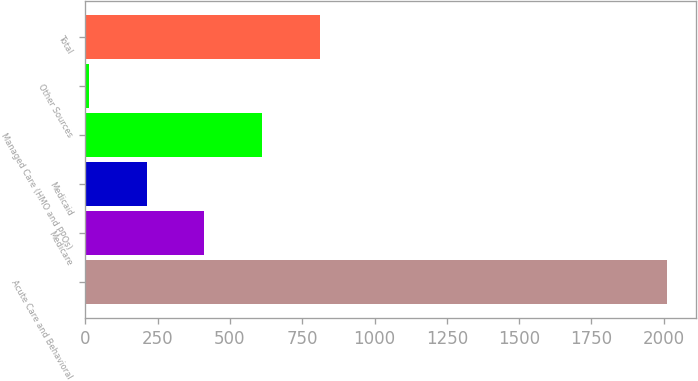Convert chart. <chart><loc_0><loc_0><loc_500><loc_500><bar_chart><fcel>Acute Care and Behavioral<fcel>Medicare<fcel>Medicaid<fcel>Managed Care (HMO and PPOs)<fcel>Other Sources<fcel>Total<nl><fcel>2011<fcel>411.8<fcel>211.9<fcel>611.7<fcel>12<fcel>811.6<nl></chart> 